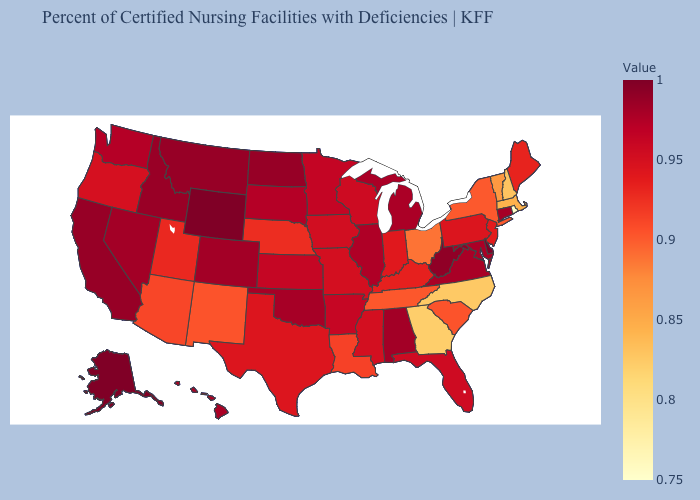Does Rhode Island have the lowest value in the USA?
Quick response, please. Yes. Does New Mexico have a lower value than Oregon?
Concise answer only. Yes. Which states have the lowest value in the USA?
Concise answer only. Rhode Island. 